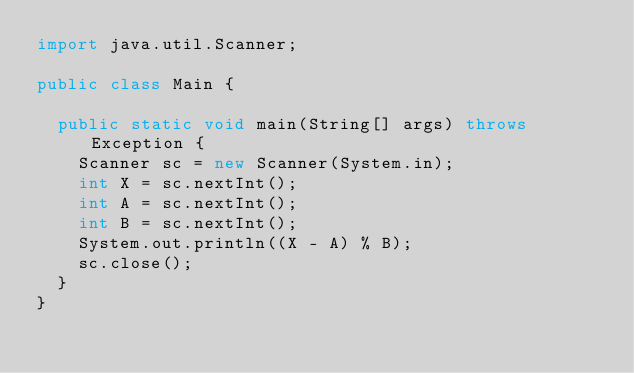Convert code to text. <code><loc_0><loc_0><loc_500><loc_500><_Java_>import java.util.Scanner;

public class Main {

	public static void main(String[] args) throws Exception {
		Scanner sc = new Scanner(System.in);
		int X = sc.nextInt();
		int A = sc.nextInt();
		int B = sc.nextInt();
		System.out.println((X - A) % B);
		sc.close();
	}
}</code> 